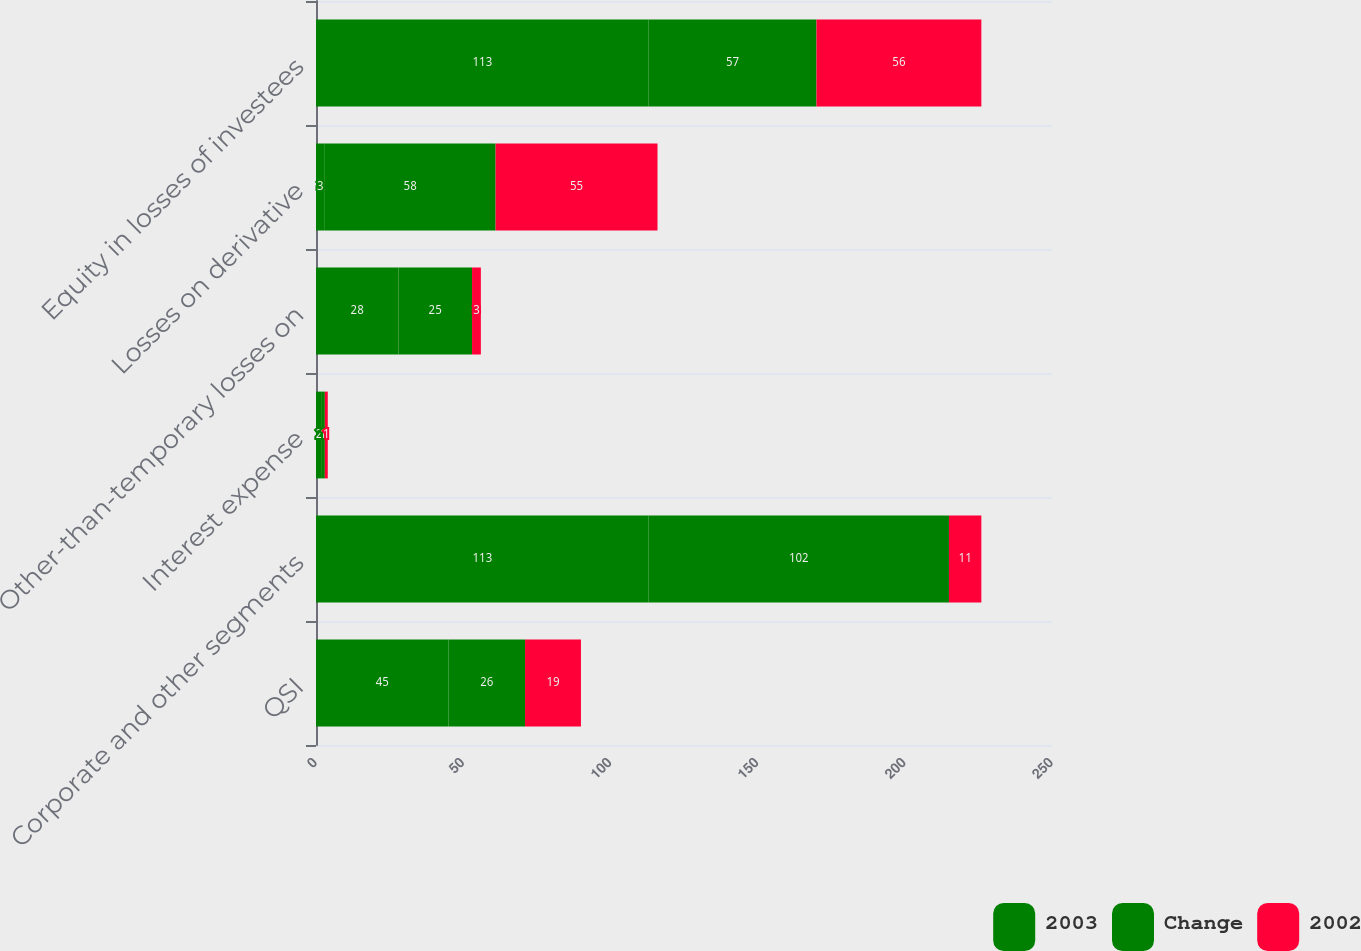Convert chart to OTSL. <chart><loc_0><loc_0><loc_500><loc_500><stacked_bar_chart><ecel><fcel>QSI<fcel>Corporate and other segments<fcel>Interest expense<fcel>Other-than-temporary losses on<fcel>Losses on derivative<fcel>Equity in losses of investees<nl><fcel>2003<fcel>45<fcel>113<fcel>2<fcel>28<fcel>3<fcel>113<nl><fcel>Change<fcel>26<fcel>102<fcel>1<fcel>25<fcel>58<fcel>57<nl><fcel>2002<fcel>19<fcel>11<fcel>1<fcel>3<fcel>55<fcel>56<nl></chart> 